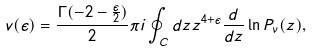Convert formula to latex. <formula><loc_0><loc_0><loc_500><loc_500>v ( \epsilon ) = \frac { \Gamma ( - 2 - \frac { \epsilon } { 2 } ) } 2 \pi i \oint _ { C } d z z ^ { 4 + \epsilon } \frac { d } { d z } \ln P _ { \nu } ( z ) ,</formula> 